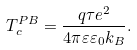Convert formula to latex. <formula><loc_0><loc_0><loc_500><loc_500>T _ { c } ^ { P B } = \frac { q \tau e ^ { 2 } } { 4 \pi \varepsilon \varepsilon _ { 0 } k _ { B } } .</formula> 